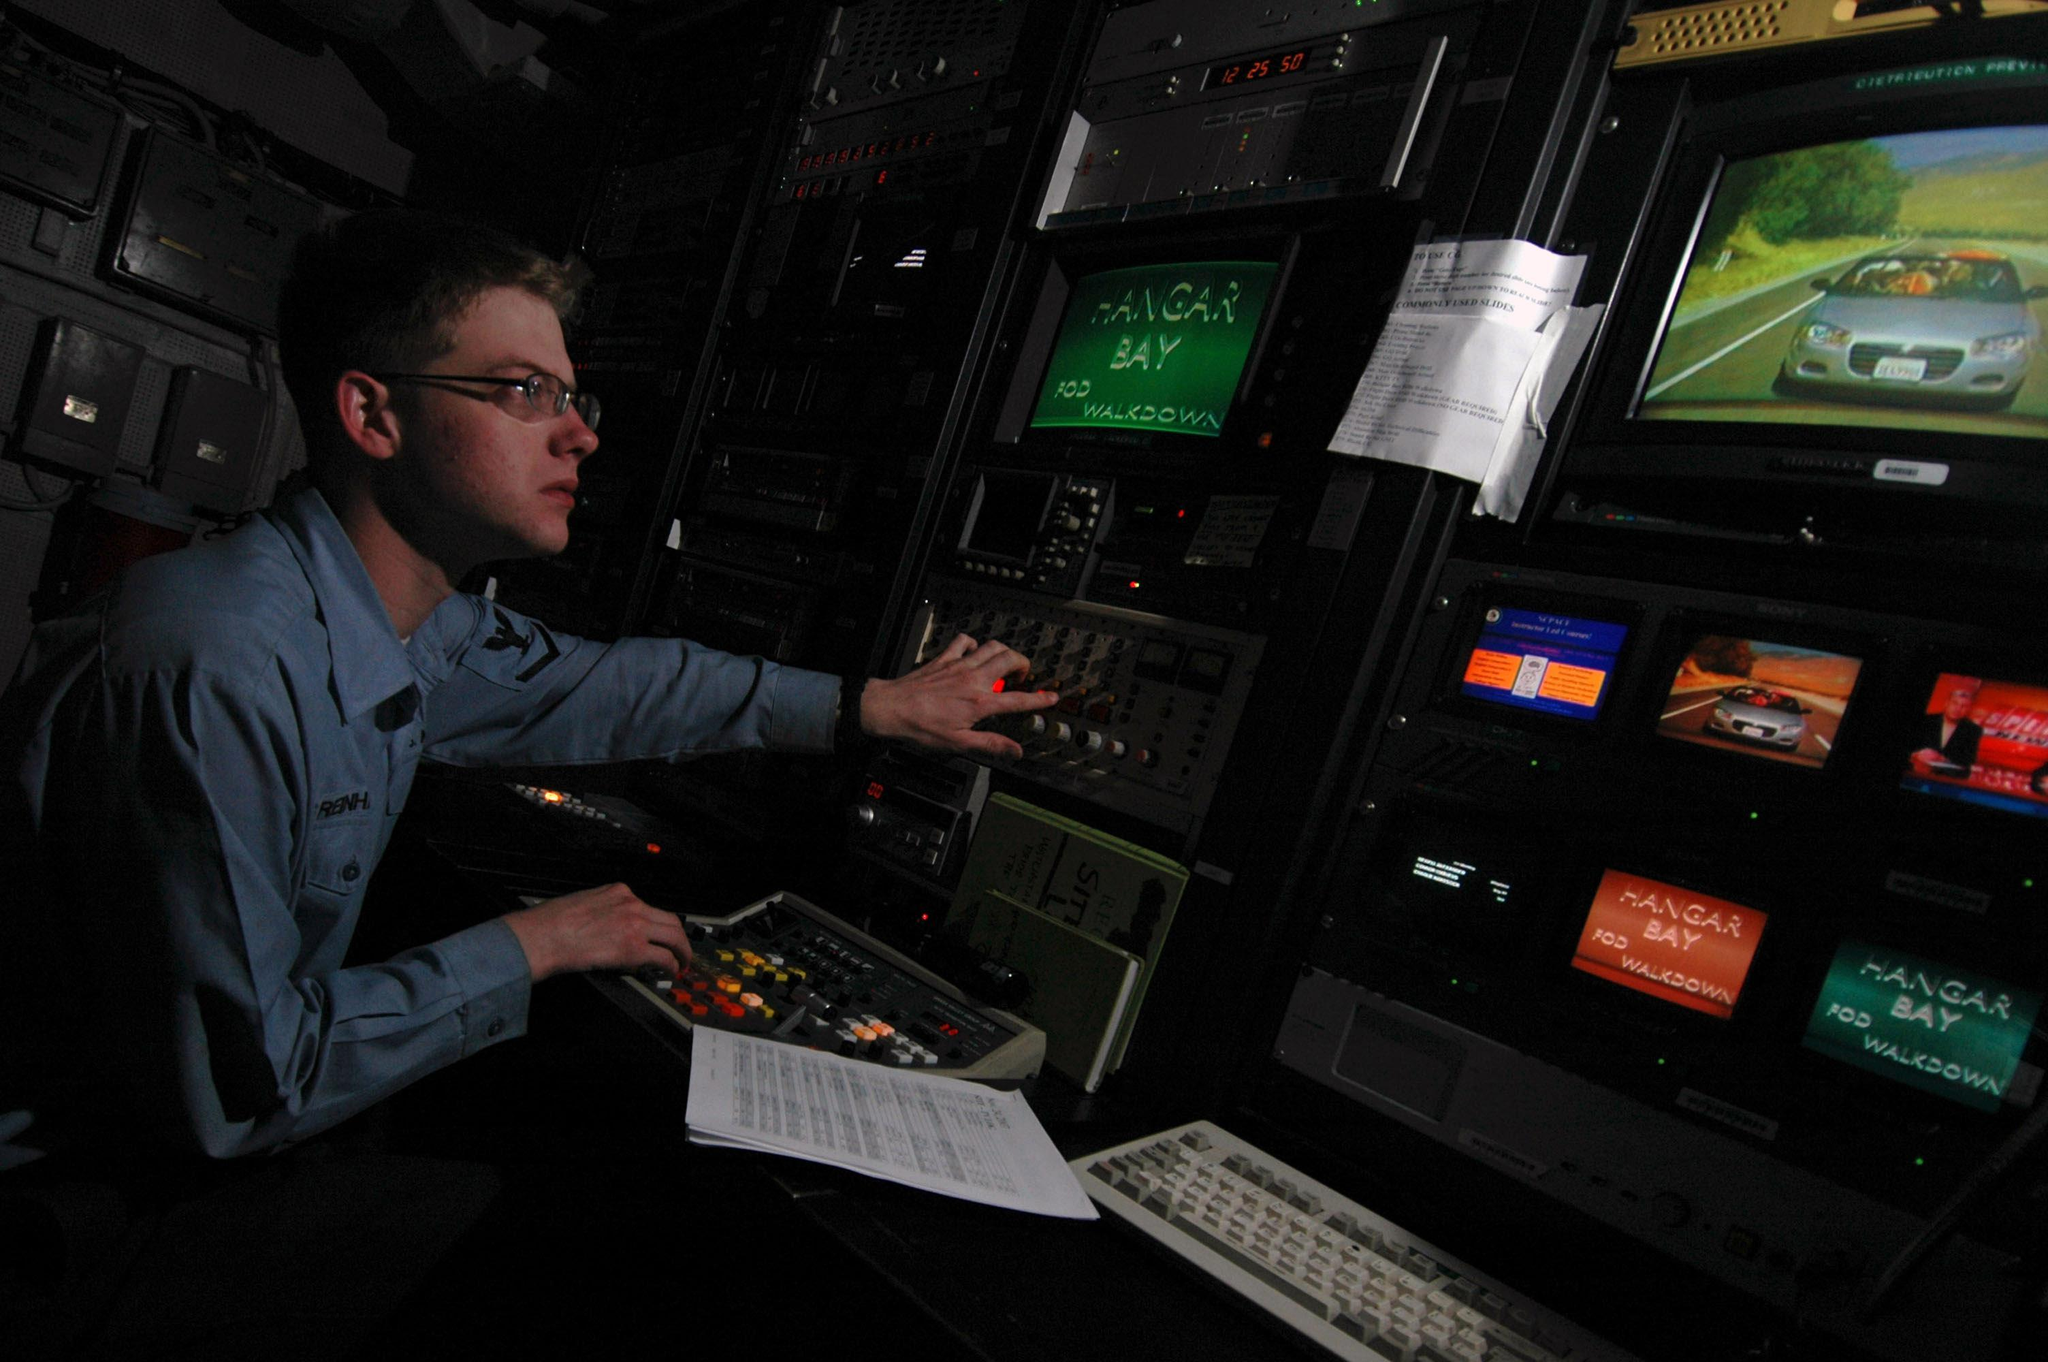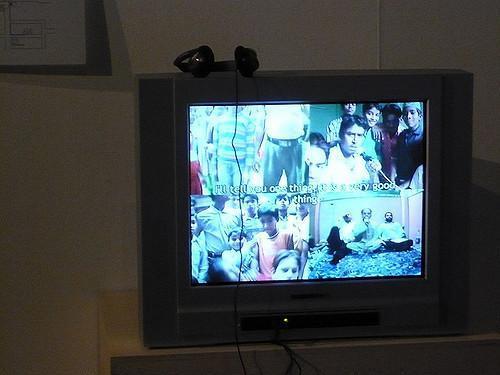The first image is the image on the left, the second image is the image on the right. Considering the images on both sides, is "An image shows the back of a man seated before many screens." valid? Answer yes or no. No. The first image is the image on the left, the second image is the image on the right. Given the left and right images, does the statement "An image shows a man reaching to touch a control panel." hold true? Answer yes or no. Yes. 